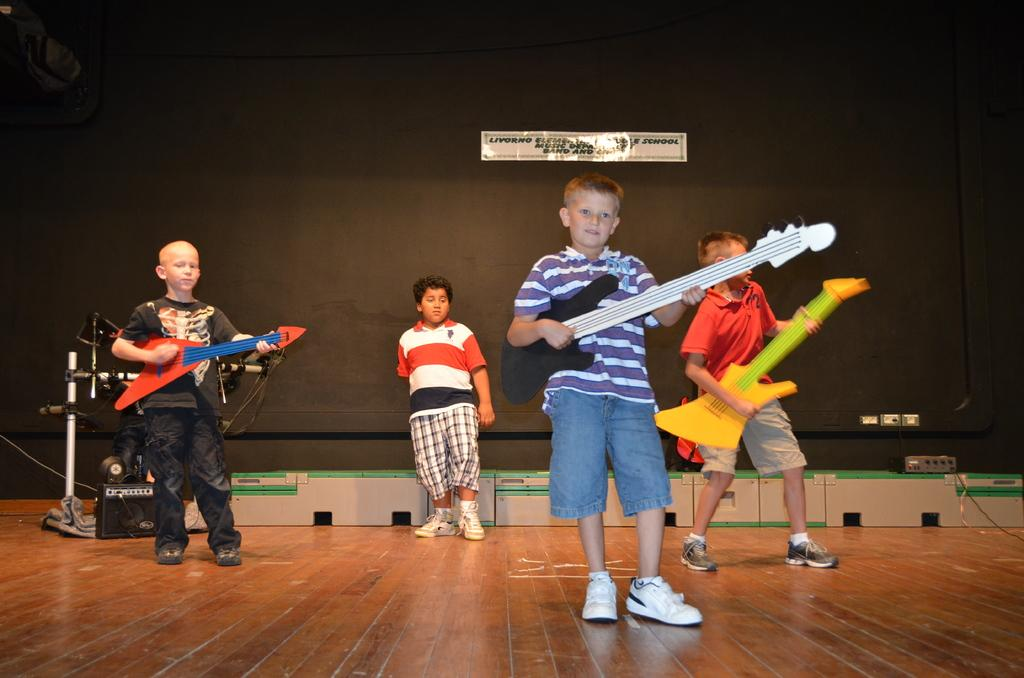How many boys are present in the image? There are 4 boys in the image. What are the boys doing in the image? Three boys in the front are playing guitar, and the person at the back is standing. What is the surface the boys are standing on? The boys are standing on a floor. What can be seen in the background of the image? There is a black wall in the background, and there is a white sticker on the black wall. How many minutes does it take for the quiver to reach the distance shown in the image? There is no quiver or distance mentioned in the image, so this question cannot be answered. 